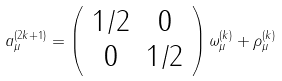<formula> <loc_0><loc_0><loc_500><loc_500>a _ { \mu } ^ { ( 2 k + 1 ) } = \left ( \begin{array} { c c } 1 / 2 & 0 \\ 0 & 1 / 2 \end{array} \right ) \omega ^ { ( k ) } _ { \mu } + \rho _ { \mu } ^ { ( k ) }</formula> 